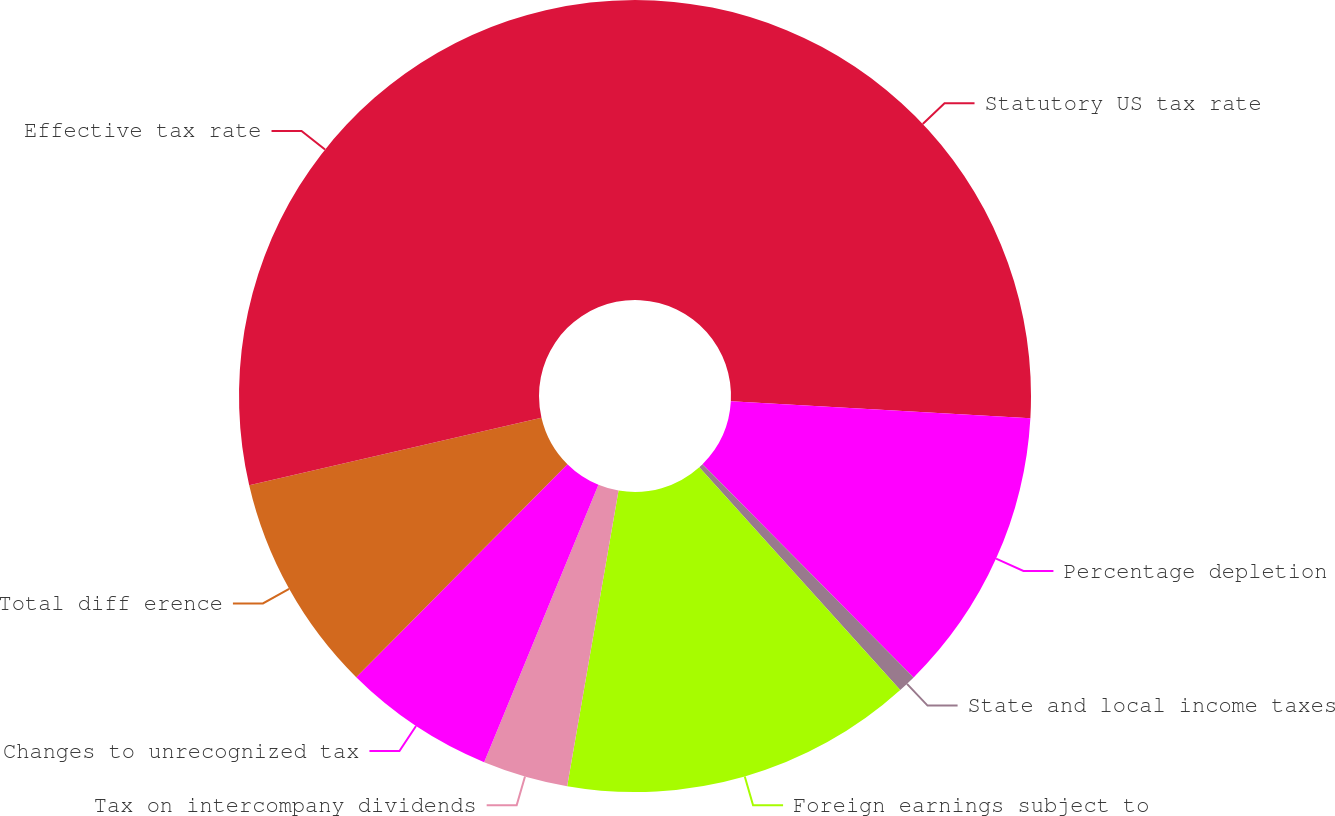Convert chart. <chart><loc_0><loc_0><loc_500><loc_500><pie_chart><fcel>Statutory US tax rate<fcel>Percentage depletion<fcel>State and local income taxes<fcel>Foreign earnings subject to<fcel>Tax on intercompany dividends<fcel>Changes to unrecognized tax<fcel>Total diff erence<fcel>Effective tax rate<nl><fcel>25.89%<fcel>11.69%<fcel>0.74%<fcel>14.42%<fcel>3.48%<fcel>6.21%<fcel>8.95%<fcel>28.62%<nl></chart> 